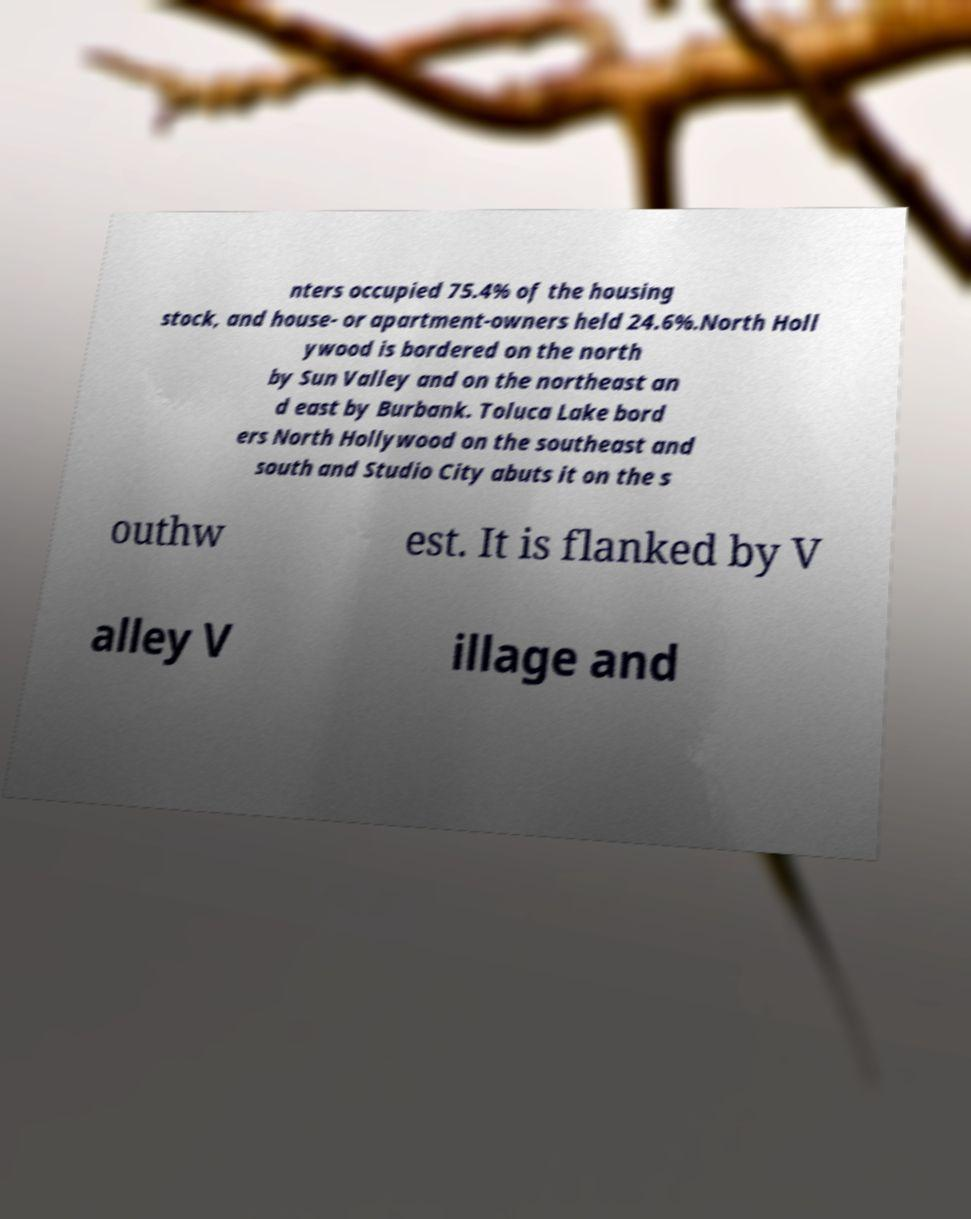Please read and relay the text visible in this image. What does it say? nters occupied 75.4% of the housing stock, and house- or apartment-owners held 24.6%.North Holl ywood is bordered on the north by Sun Valley and on the northeast an d east by Burbank. Toluca Lake bord ers North Hollywood on the southeast and south and Studio City abuts it on the s outhw est. It is flanked by V alley V illage and 